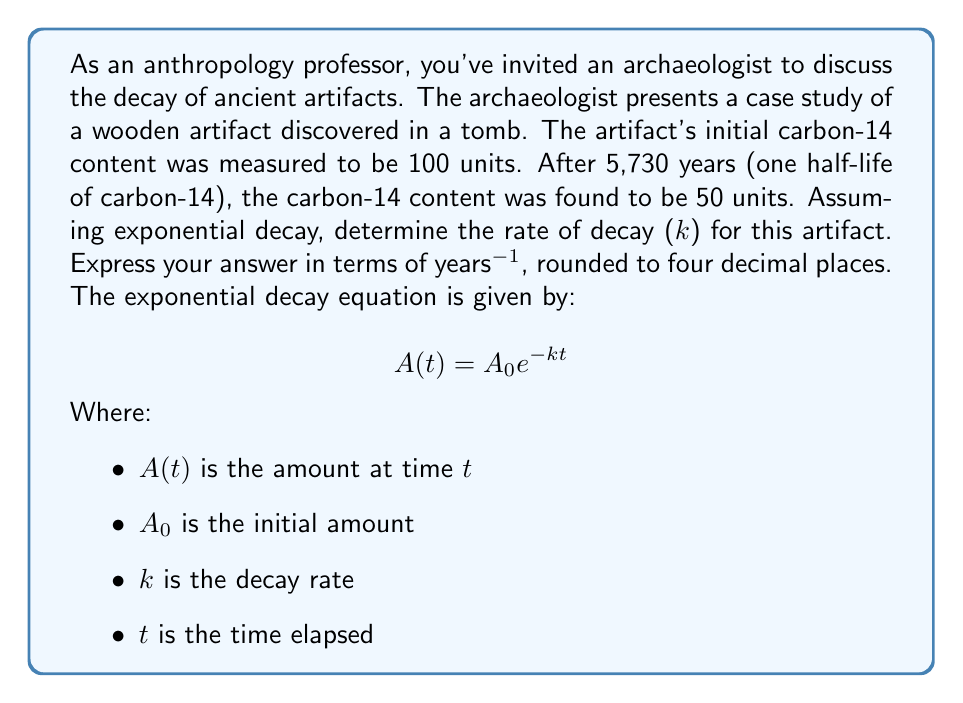Provide a solution to this math problem. To solve this problem, we'll use the exponential decay equation and the given information:

1) Initial amount $A_0 = 100$ units
2) Amount after one half-life $A(5730) = 50$ units
3) Time elapsed $t = 5730$ years

Let's substitute these values into the exponential decay equation:

$$50 = 100 e^{-k(5730)}$$

Now, let's solve for $k$:

1) Divide both sides by 100:
   $$0.5 = e^{-k(5730)}$$

2) Take the natural logarithm of both sides:
   $$\ln(0.5) = -k(5730)$$

3) Solve for $k$:
   $$k = -\frac{\ln(0.5)}{5730}$$

4) Calculate the value:
   $$k = -\frac{-0.69314718...}{5730} \approx 0.0001209549...$$

5) Round to four decimal places:
   $$k \approx 0.0001$$
Answer: The rate of decay (k) for the artifact is approximately $0.0001$ years^(-1). 